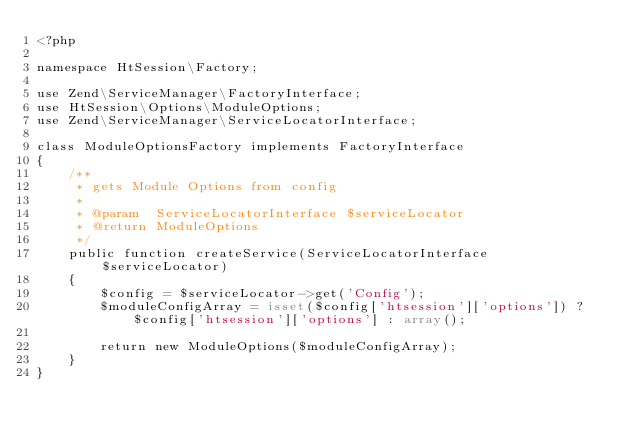Convert code to text. <code><loc_0><loc_0><loc_500><loc_500><_PHP_><?php

namespace HtSession\Factory;

use Zend\ServiceManager\FactoryInterface;
use HtSession\Options\ModuleOptions;
use Zend\ServiceManager\ServiceLocatorInterface;

class ModuleOptionsFactory implements FactoryInterface
{
    /**
     * gets Module Options from config
     *
     * @param  ServiceLocatorInterface $serviceLocator
     * @return ModuleOptions
     */
    public function createService(ServiceLocatorInterface $serviceLocator)
    {
        $config = $serviceLocator->get('Config');
        $moduleConfigArray = isset($config['htsession']['options']) ? $config['htsession']['options'] : array();

        return new ModuleOptions($moduleConfigArray);
    }
}
</code> 